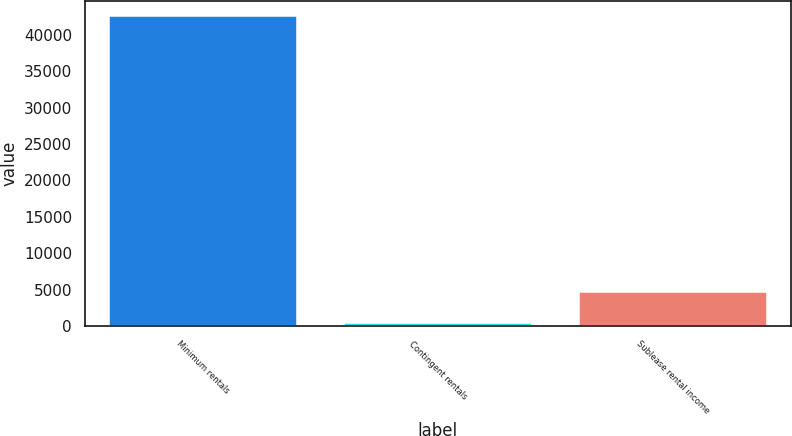Convert chart. <chart><loc_0><loc_0><loc_500><loc_500><bar_chart><fcel>Minimum rentals<fcel>Contingent rentals<fcel>Sublease rental income<nl><fcel>42506<fcel>431<fcel>4638.5<nl></chart> 